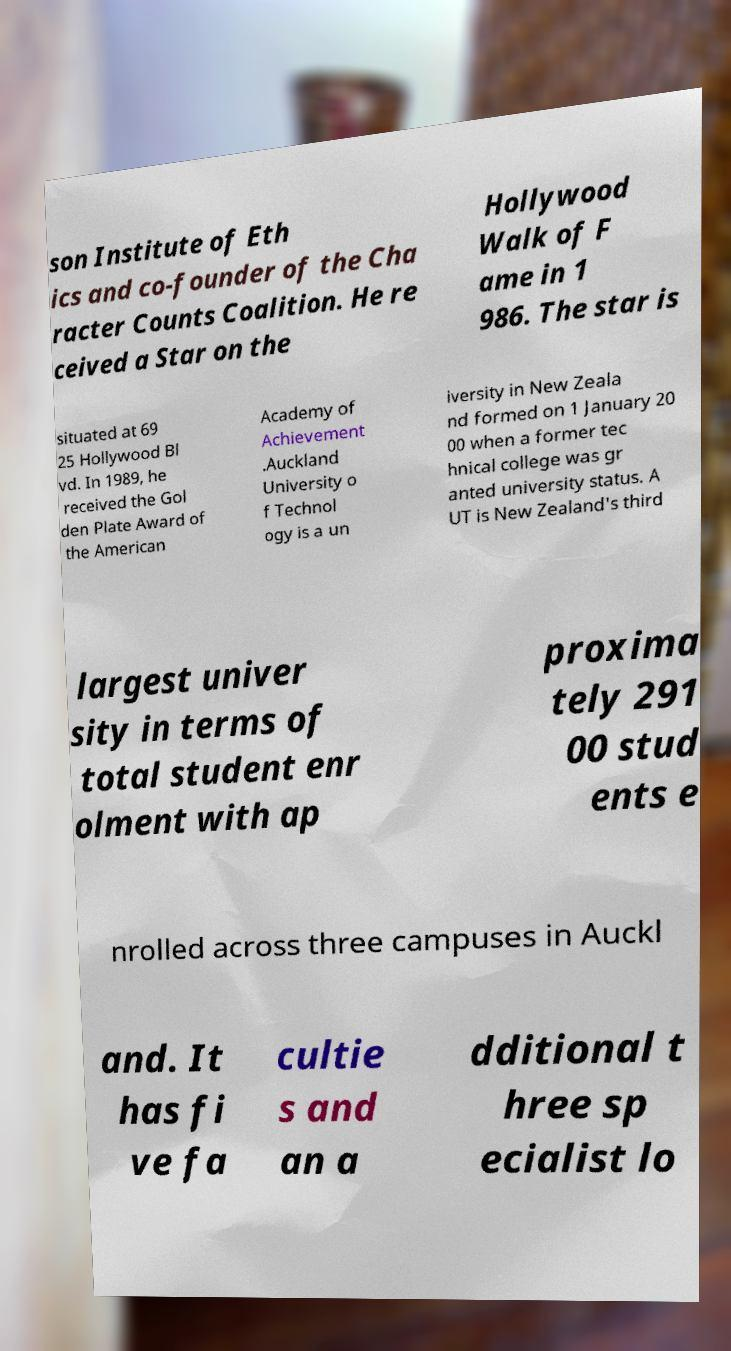Please identify and transcribe the text found in this image. son Institute of Eth ics and co-founder of the Cha racter Counts Coalition. He re ceived a Star on the Hollywood Walk of F ame in 1 986. The star is situated at 69 25 Hollywood Bl vd. In 1989, he received the Gol den Plate Award of the American Academy of Achievement .Auckland University o f Technol ogy is a un iversity in New Zeala nd formed on 1 January 20 00 when a former tec hnical college was gr anted university status. A UT is New Zealand's third largest univer sity in terms of total student enr olment with ap proxima tely 291 00 stud ents e nrolled across three campuses in Auckl and. It has fi ve fa cultie s and an a dditional t hree sp ecialist lo 